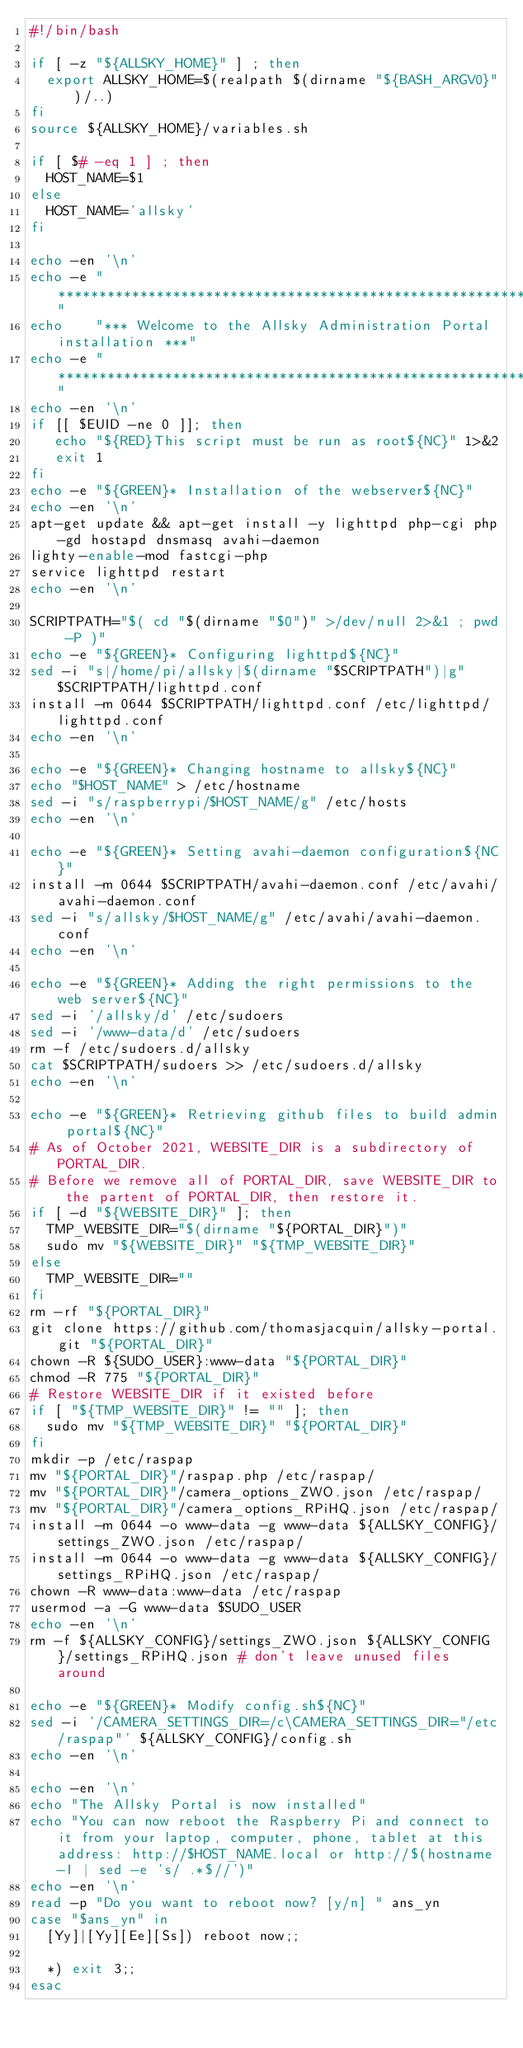<code> <loc_0><loc_0><loc_500><loc_500><_Bash_>#!/bin/bash

if [ -z "${ALLSKY_HOME}" ] ; then
	export ALLSKY_HOME=$(realpath $(dirname "${BASH_ARGV0}")/..)
fi
source ${ALLSKY_HOME}/variables.sh

if [ $# -eq 1 ] ; then
	HOST_NAME=$1
else
	HOST_NAME='allsky'
fi

echo -en '\n'
echo -e "****************************************************************"
echo    "*** Welcome to the Allsky Administration Portal installation ***"
echo -e "****************************************************************"
echo -en '\n'
if [[ $EUID -ne 0 ]]; then
   echo "${RED}This script must be run as root${NC}" 1>&2
   exit 1
fi
echo -e "${GREEN}* Installation of the webserver${NC}"
echo -en '\n'
apt-get update && apt-get install -y lighttpd php-cgi php-gd hostapd dnsmasq avahi-daemon
lighty-enable-mod fastcgi-php
service lighttpd restart
echo -en '\n'

SCRIPTPATH="$( cd "$(dirname "$0")" >/dev/null 2>&1 ; pwd -P )"
echo -e "${GREEN}* Configuring lighttpd${NC}"
sed -i "s|/home/pi/allsky|$(dirname "$SCRIPTPATH")|g" $SCRIPTPATH/lighttpd.conf
install -m 0644 $SCRIPTPATH/lighttpd.conf /etc/lighttpd/lighttpd.conf
echo -en '\n'

echo -e "${GREEN}* Changing hostname to allsky${NC}"
echo "$HOST_NAME" > /etc/hostname
sed -i "s/raspberrypi/$HOST_NAME/g" /etc/hosts
echo -en '\n'

echo -e "${GREEN}* Setting avahi-daemon configuration${NC}"
install -m 0644 $SCRIPTPATH/avahi-daemon.conf /etc/avahi/avahi-daemon.conf
sed -i "s/allsky/$HOST_NAME/g" /etc/avahi/avahi-daemon.conf
echo -en '\n'

echo -e "${GREEN}* Adding the right permissions to the web server${NC}"
sed -i '/allsky/d' /etc/sudoers
sed -i '/www-data/d' /etc/sudoers
rm -f /etc/sudoers.d/allsky
cat $SCRIPTPATH/sudoers >> /etc/sudoers.d/allsky
echo -en '\n'

echo -e "${GREEN}* Retrieving github files to build admin portal${NC}"
# As of October 2021, WEBSITE_DIR is a subdirectory of PORTAL_DIR.
# Before we remove all of PORTAL_DIR, save WEBSITE_DIR to the partent of PORTAL_DIR, then restore it.
if [ -d "${WEBSITE_DIR}" ]; then
	TMP_WEBSITE_DIR="$(dirname "${PORTAL_DIR}")"
	sudo mv "${WEBSITE_DIR}" "${TMP_WEBSITE_DIR}"
else
	TMP_WEBSITE_DIR=""
fi
rm -rf "${PORTAL_DIR}"
git clone https://github.com/thomasjacquin/allsky-portal.git "${PORTAL_DIR}"
chown -R ${SUDO_USER}:www-data "${PORTAL_DIR}"
chmod -R 775 "${PORTAL_DIR}"
# Restore WEBSITE_DIR if it existed before
if [ "${TMP_WEBSITE_DIR}" != "" ]; then
	sudo mv "${TMP_WEBSITE_DIR}" "${PORTAL_DIR}"
fi
mkdir -p /etc/raspap
mv "${PORTAL_DIR}"/raspap.php /etc/raspap/
mv "${PORTAL_DIR}"/camera_options_ZWO.json /etc/raspap/
mv "${PORTAL_DIR}"/camera_options_RPiHQ.json /etc/raspap/
install -m 0644 -o www-data -g www-data ${ALLSKY_CONFIG}/settings_ZWO.json /etc/raspap/
install -m 0644 -o www-data -g www-data ${ALLSKY_CONFIG}/settings_RPiHQ.json /etc/raspap/
chown -R www-data:www-data /etc/raspap
usermod -a -G www-data $SUDO_USER
echo -en '\n'
rm -f ${ALLSKY_CONFIG}/settings_ZWO.json ${ALLSKY_CONFIG}/settings_RPiHQ.json	# don't leave unused files around

echo -e "${GREEN}* Modify config.sh${NC}"
sed -i '/CAMERA_SETTINGS_DIR=/c\CAMERA_SETTINGS_DIR="/etc/raspap"' ${ALLSKY_CONFIG}/config.sh
echo -en '\n'

echo -en '\n'
echo "The Allsky Portal is now installed"
echo "You can now reboot the Raspberry Pi and connect to it from your laptop, computer, phone, tablet at this address: http://$HOST_NAME.local or http://$(hostname -I | sed -e 's/ .*$//')"
echo -en '\n'
read -p "Do you want to reboot now? [y/n] " ans_yn
case "$ans_yn" in
  [Yy]|[Yy][Ee][Ss]) reboot now;;

  *) exit 3;;
esac
</code> 